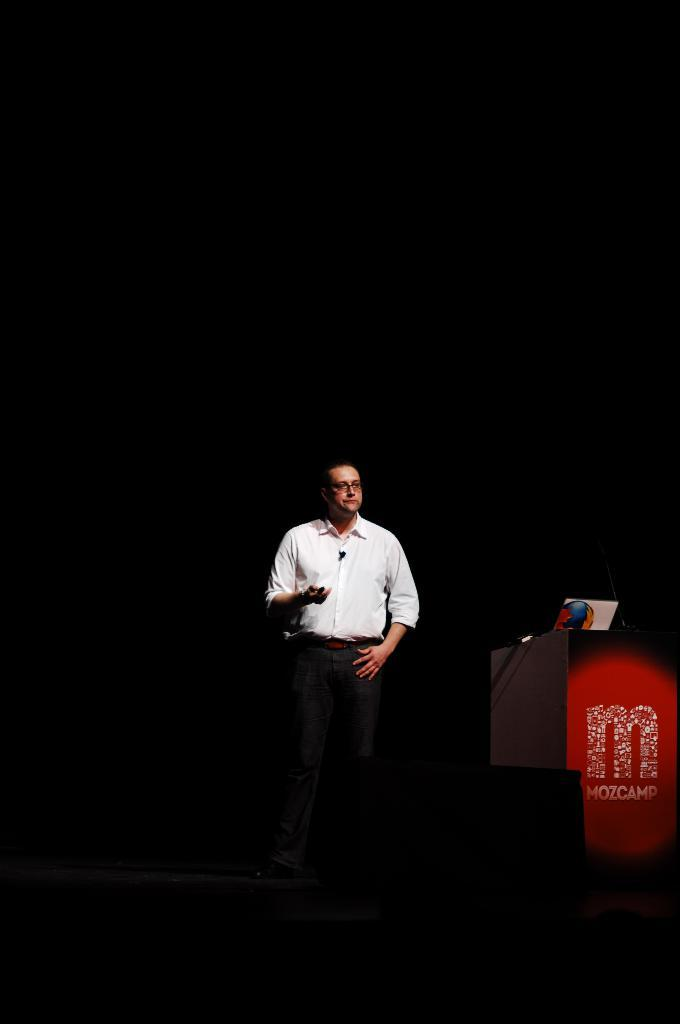Who is the main subject in the image? There is a person in the image. What is the person doing in the image? The person is speaking into a microphone. What object can be seen on the right side of the image? There is a podium on the right side of the image. How many divisions of birds are visible in the image? There are no birds present in the image, so it is not possible to determine the number of divisions. 